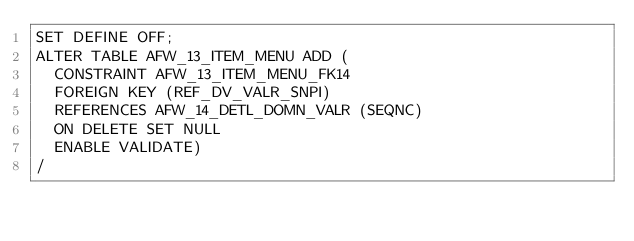Convert code to text. <code><loc_0><loc_0><loc_500><loc_500><_SQL_>SET DEFINE OFF;
ALTER TABLE AFW_13_ITEM_MENU ADD (
  CONSTRAINT AFW_13_ITEM_MENU_FK14 
  FOREIGN KEY (REF_DV_VALR_SNPI) 
  REFERENCES AFW_14_DETL_DOMN_VALR (SEQNC)
  ON DELETE SET NULL
  ENABLE VALIDATE)
/
</code> 